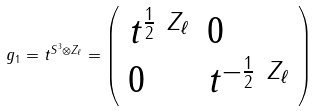Convert formula to latex. <formula><loc_0><loc_0><loc_500><loc_500>g _ { 1 } = t ^ { S ^ { 3 } \otimes Z _ { \ell } } = \left ( \begin{array} { l l } t ^ { \frac { 1 } { 2 } \ Z _ { \ell } } & 0 \\ 0 & t ^ { - \frac { 1 } { 2 } \ Z _ { \ell } } \end{array} \right )</formula> 